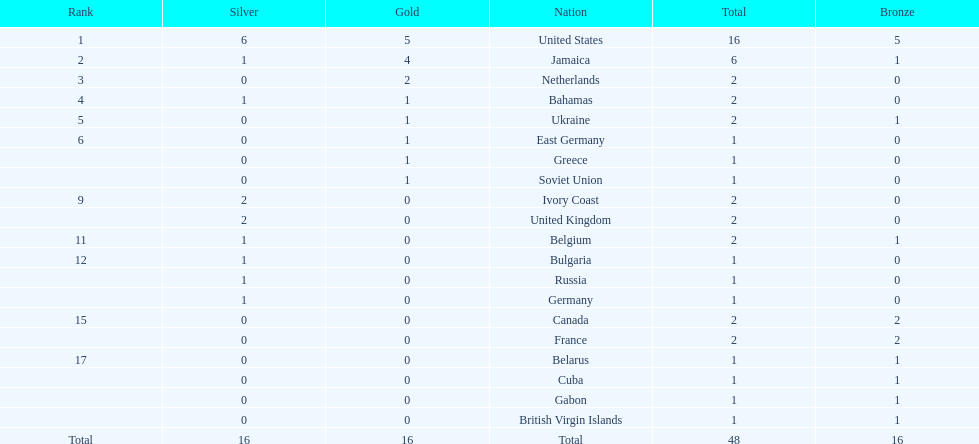How many gold medals did the us and jamaica win combined? 9. 